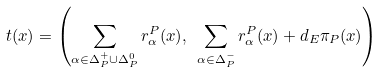<formula> <loc_0><loc_0><loc_500><loc_500>t ( x ) = \left ( \sum _ { \alpha \in \Delta _ { P } ^ { + } \cup \Delta _ { P } ^ { 0 } } r _ { \alpha } ^ { P } ( x ) , \ \sum _ { \alpha \in \Delta _ { P } ^ { - } } r _ { \alpha } ^ { P } ( x ) + d _ { E } \pi _ { P } ( x ) \right )</formula> 